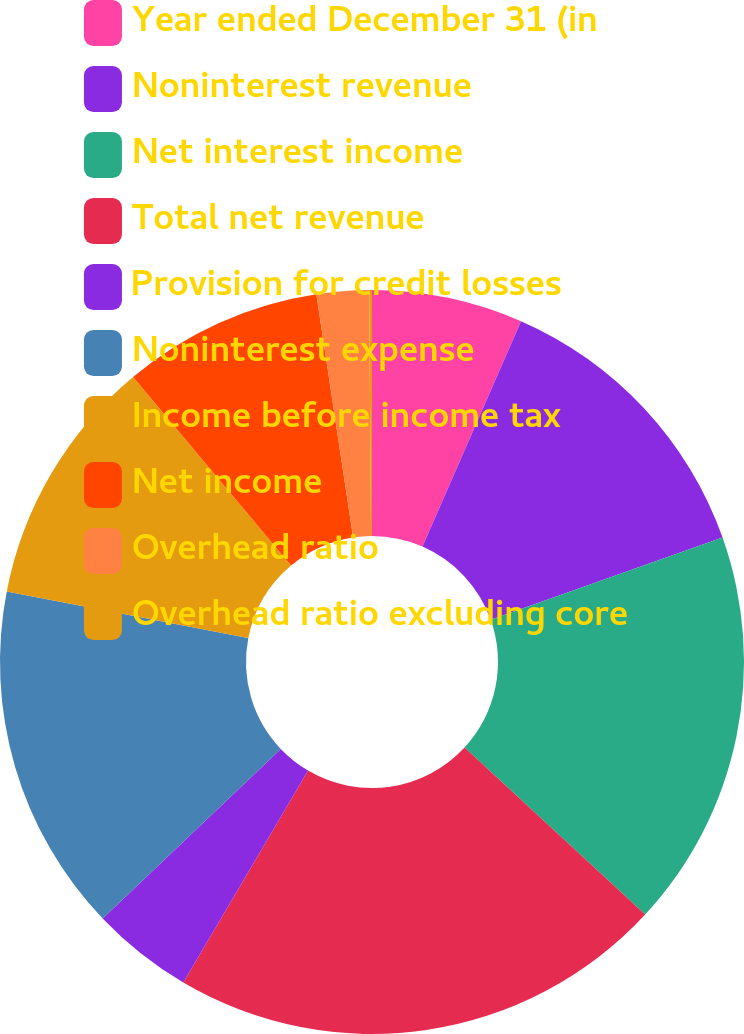Convert chart. <chart><loc_0><loc_0><loc_500><loc_500><pie_chart><fcel>Year ended December 31 (in<fcel>Noninterest revenue<fcel>Net interest income<fcel>Total net revenue<fcel>Provision for credit losses<fcel>Noninterest expense<fcel>Income before income tax<fcel>Net income<fcel>Overhead ratio<fcel>Overhead ratio excluding core<nl><fcel>6.56%<fcel>13.01%<fcel>17.3%<fcel>21.59%<fcel>4.42%<fcel>15.15%<fcel>10.86%<fcel>8.71%<fcel>2.27%<fcel>0.12%<nl></chart> 